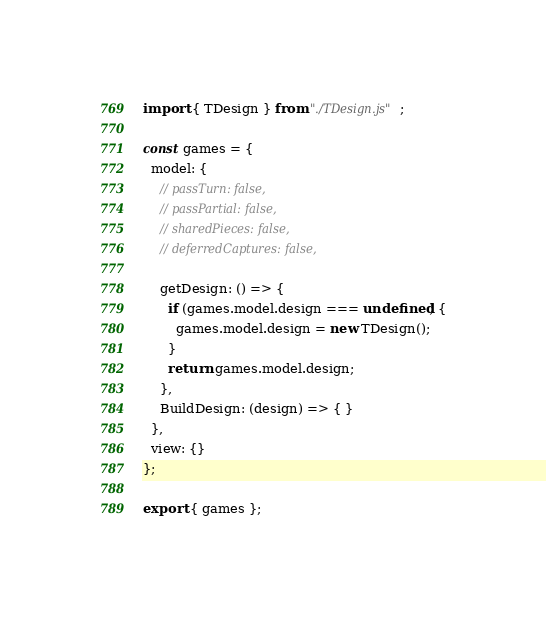<code> <loc_0><loc_0><loc_500><loc_500><_JavaScript_>import { TDesign } from "./TDesign.js";

const games = {
  model: {
    // passTurn: false,
    // passPartial: false,
    // sharedPieces: false,
    // deferredCaptures: false,

    getDesign: () => {
      if (games.model.design === undefined) {
        games.model.design = new TDesign();
      }
      return games.model.design;
    },
    BuildDesign: (design) => { }
  },
  view: {}
};

export { games };
</code> 